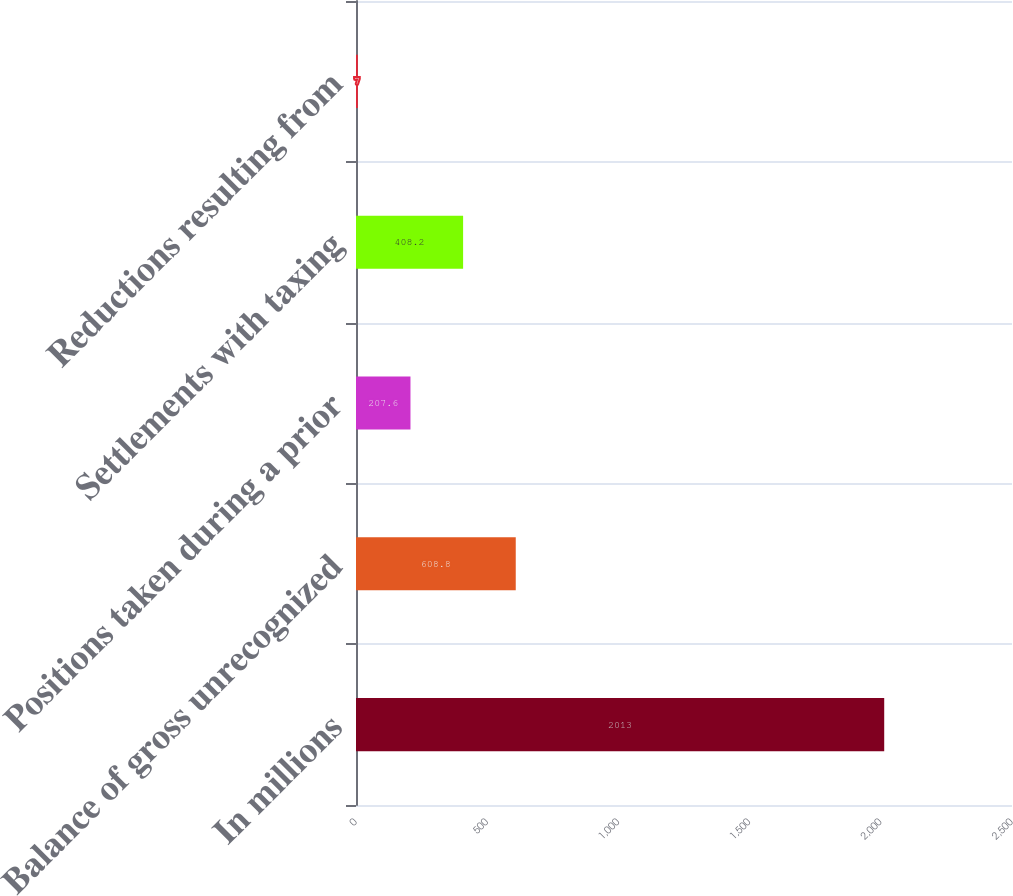Convert chart. <chart><loc_0><loc_0><loc_500><loc_500><bar_chart><fcel>In millions<fcel>Balance of gross unrecognized<fcel>Positions taken during a prior<fcel>Settlements with taxing<fcel>Reductions resulting from<nl><fcel>2013<fcel>608.8<fcel>207.6<fcel>408.2<fcel>7<nl></chart> 